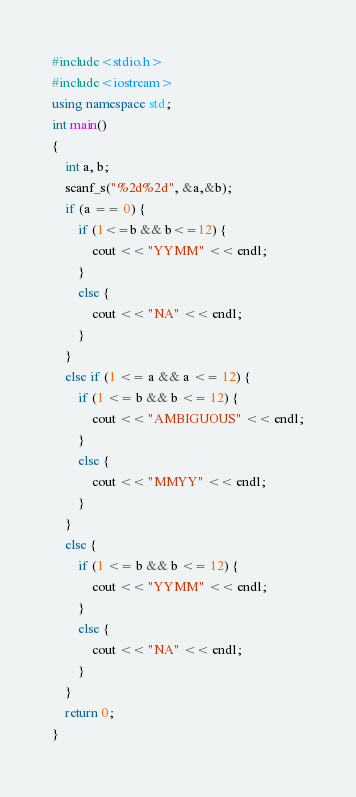Convert code to text. <code><loc_0><loc_0><loc_500><loc_500><_C++_>#include<stdio.h>
#include<iostream>
using namespace std;
int main()
{
	int a, b;
	scanf_s("%2d%2d", &a,&b);
	if (a == 0) {
		if (1<=b && b<=12) {
			cout << "YYMM" << endl;
		}
		else {
			cout << "NA" << endl;
		}
	}
	else if (1 <= a && a <= 12) {
		if (1 <= b && b <= 12) {
			cout << "AMBIGUOUS" << endl;
		}
		else {
			cout << "MMYY" << endl;
		}
	}
	else {
		if (1 <= b && b <= 12) {
			cout << "YYMM" << endl;
		}
		else {
			cout << "NA" << endl;
		}
	}
	return 0;
}
</code> 